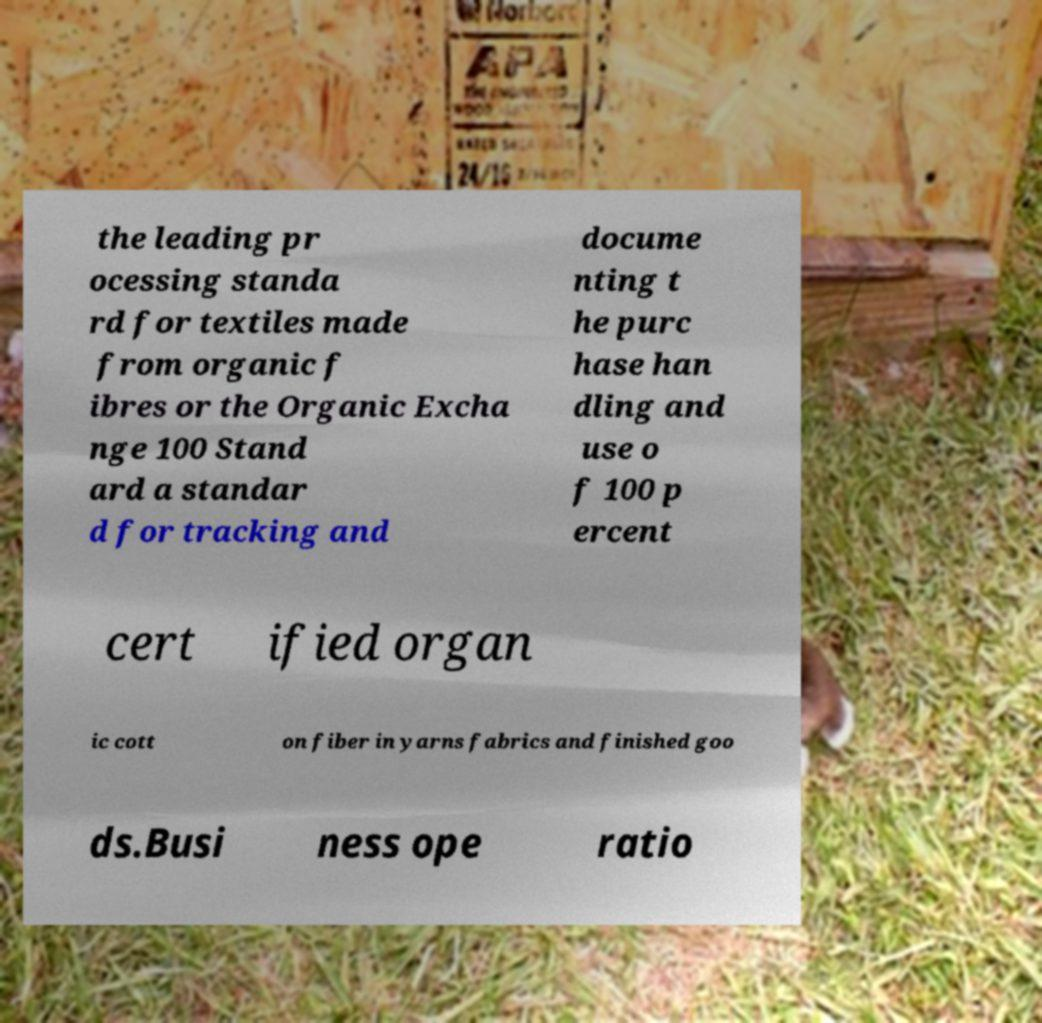Can you accurately transcribe the text from the provided image for me? the leading pr ocessing standa rd for textiles made from organic f ibres or the Organic Excha nge 100 Stand ard a standar d for tracking and docume nting t he purc hase han dling and use o f 100 p ercent cert ified organ ic cott on fiber in yarns fabrics and finished goo ds.Busi ness ope ratio 